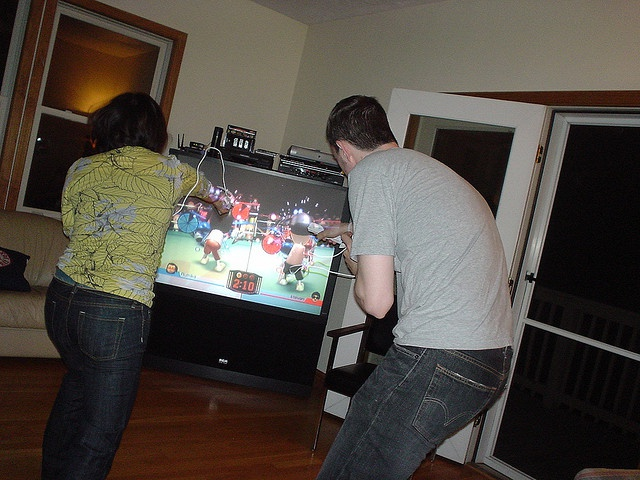Describe the objects in this image and their specific colors. I can see people in black, darkgray, and gray tones, people in black, olive, and gray tones, tv in black, gray, ivory, and darkgray tones, couch in black and gray tones, and chair in black and gray tones in this image. 